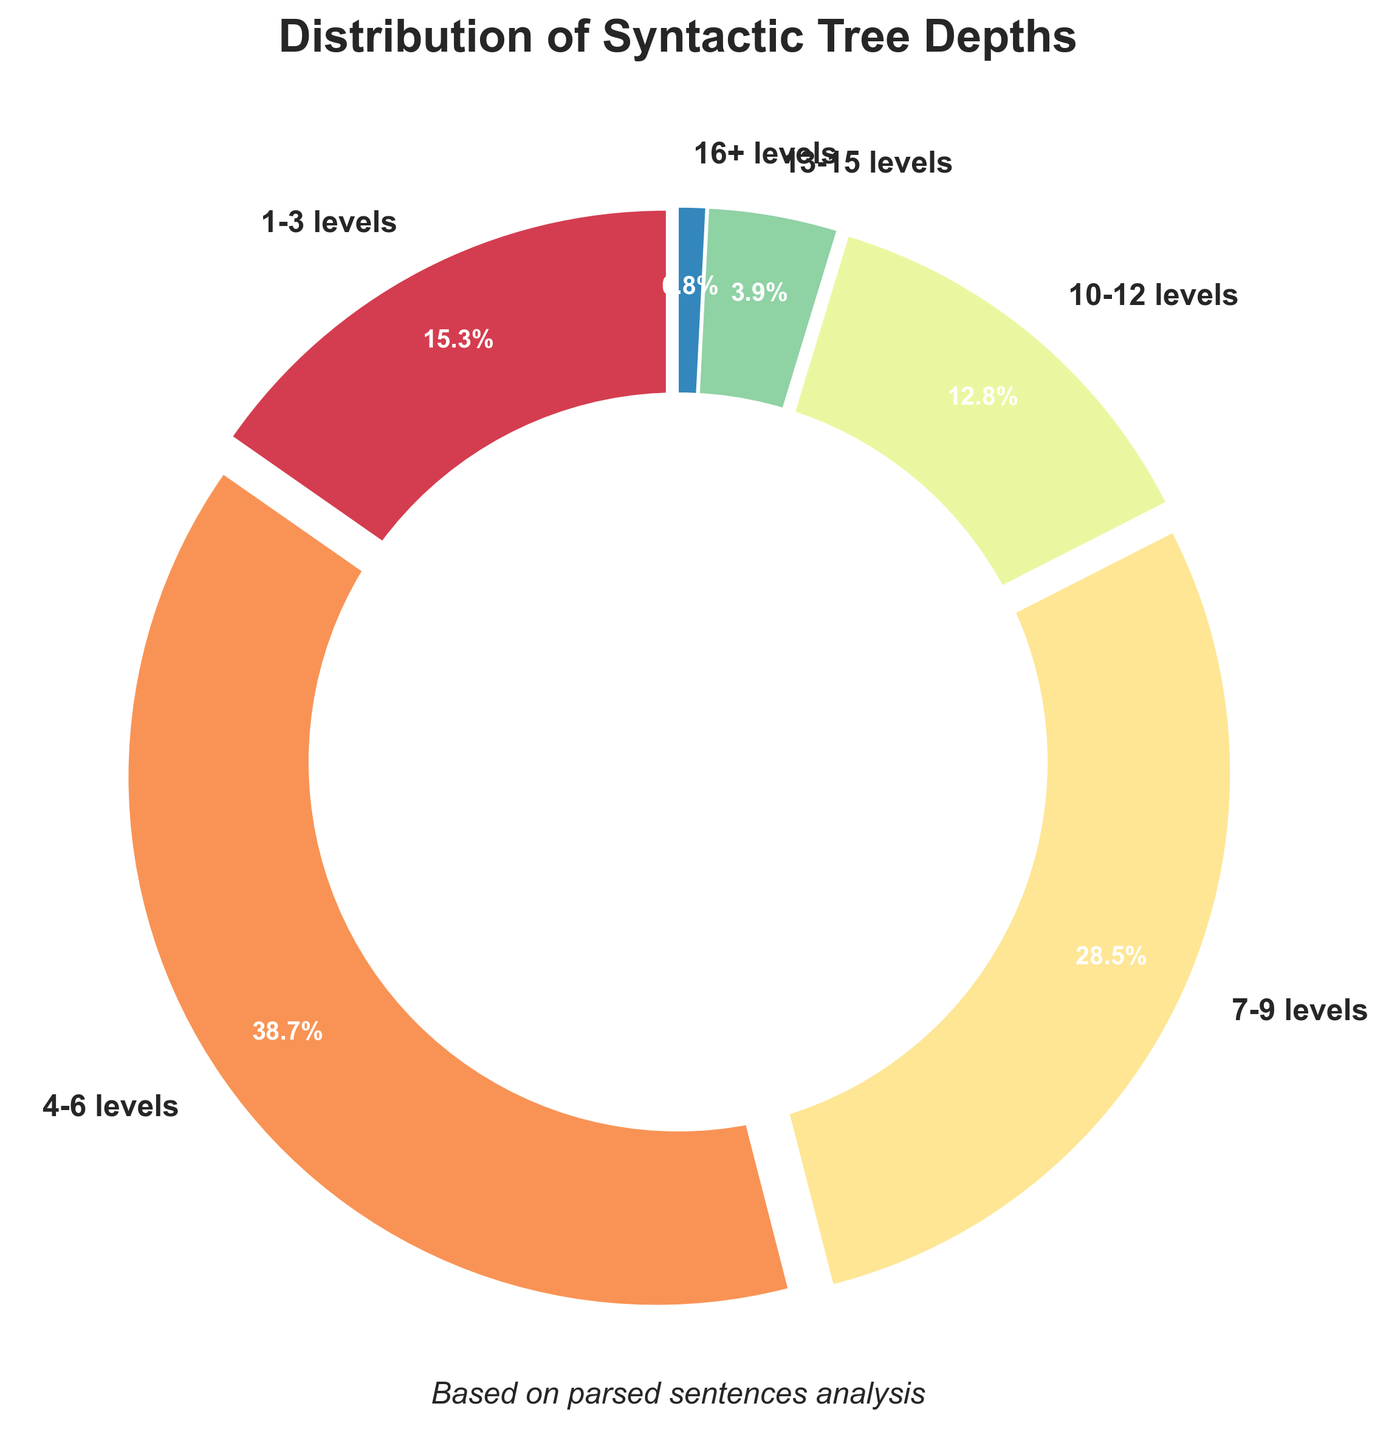What is the percentage of syntactic trees with depths between 4-6 levels? Directly look at the section of the pie chart labeled "4-6 levels," which shows 38.7%.
Answer: 38.7% Which range of tree depths has the smallest percentage? Identify the segment of the pie chart with the smallest slice, which is labeled "16+ levels" with 0.8%.
Answer: 16+ levels If you combine the percentages of tree depths from 1-3 levels and 13-15 levels, what is the total percentage? Add the percentages from the segments "1-3 levels" (15.3%) and "13-15 levels" (3.9%), so 15.3% + 3.9% = 19.2%.
Answer: 19.2% Considering tree depths of 7-9 levels and 10-12 levels together, what percentage do they represent? Sum the percentages from the two segments: "7-9 levels" (28.5%) and "10-12 levels" (12.8%). So, 28.5% + 12.8% = 41.3%.
Answer: 41.3% How does the percentage of tree depths between 4-6 levels compare to those between 10-12 levels? Compare the numbers directly: 38.7% for 4-6 levels and 12.8% for 10-12 levels. 38.7% is greater than 12.8%.
Answer: Greater Which tree depth range appears in the most vivid color? Look for the segment that has the most visually striking color, which will often be one of the more extreme colors in the colormap used (e.g., red or bright colors). Assuming a vivid color means the largest visual impact segment, the answer might depend on the generated colormap but usually corresponds to one of the more central percentages like 4-6 levels (38.7%).
Answer: 4-6 levels Which range of tree depths accounts for a larger percentage than both 1-3 levels and 13-15 levels combined? Sum percentages of 1-3 levels (15.3%) and 13-15 levels (3.9%) which is 19.2%. Then identify segments larger than 19.2%, notably 4-6 levels (38.7%) and 7-9 levels (28.5%).
Answer: 4-6 levels and 7-9 levels What is the visual impact of the "4-6 levels" segment compared to "16+ levels" segment? The "4-6 levels" segment is significantly larger, taking up a much larger arc of the pie chart and a more filled color, implying a much higher percentage (38.7% compared to 0.8%).
Answer: Much larger Is the sum of the percentages for tree depths of less than 7 levels more or less than 50%? Add the percentages of "1-3 levels" (15.3%) and "4-6 levels" (38.7%) which gives 15.3% + 38.7% = 54%. Since 54% is more than 50%, the answer is more.
Answer: More 